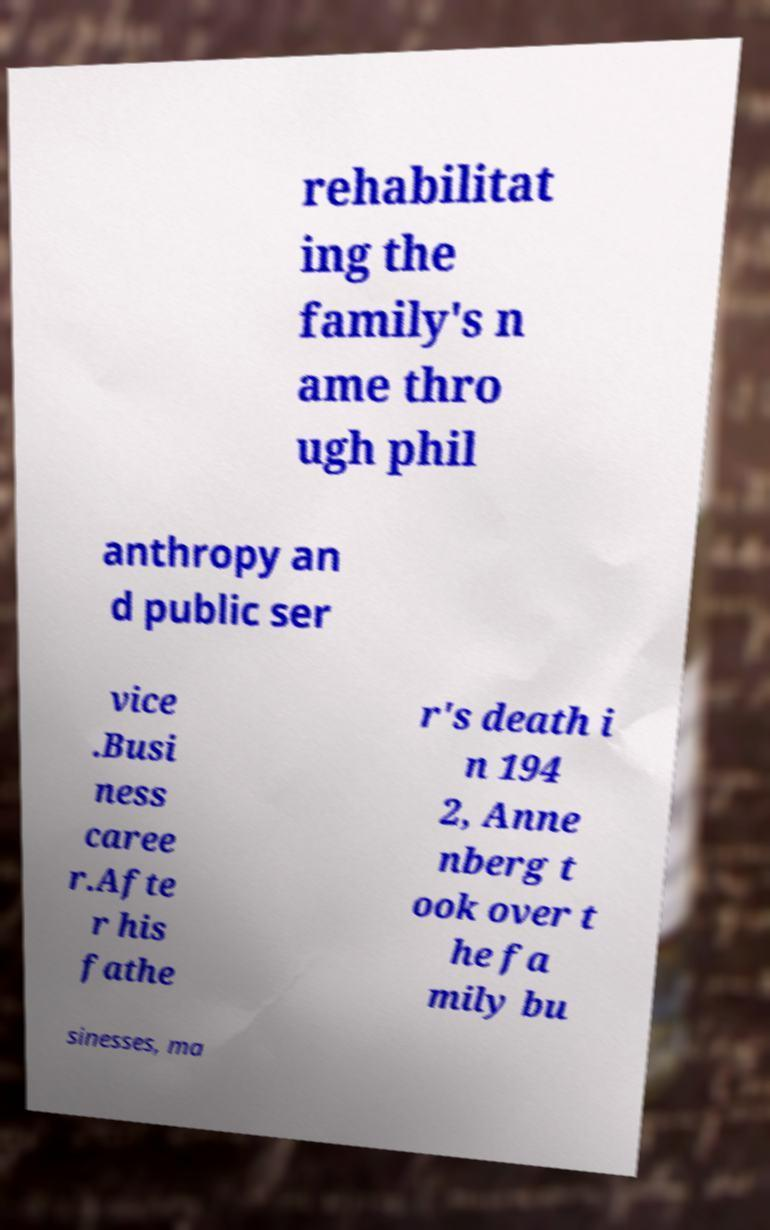Could you assist in decoding the text presented in this image and type it out clearly? rehabilitat ing the family's n ame thro ugh phil anthropy an d public ser vice .Busi ness caree r.Afte r his fathe r's death i n 194 2, Anne nberg t ook over t he fa mily bu sinesses, ma 